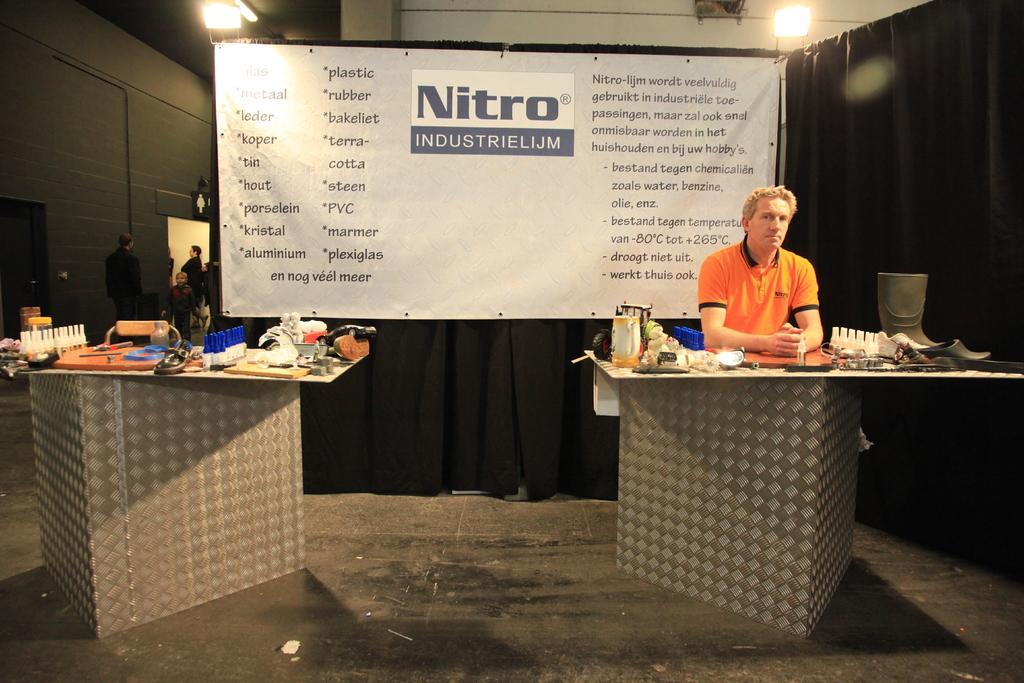Could you give a brief overview of what you see in this image? In this image we can see a person wearing orange color T-shirt standing behind podium on which there are some objects and on left side of the image there is another podium on which there are some objects and in the background of the image there is black color curtain and there is white color sheet on which there are some words printed, there are some persons standing near the wall and there are some lights. 